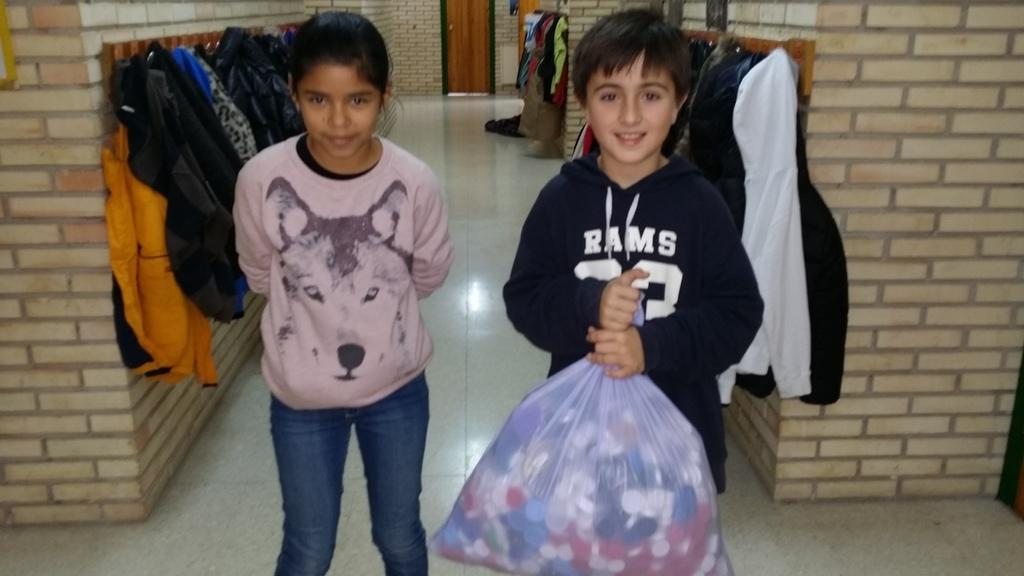How many people are in the image? There are two people in the image, a girl and a boy. What is the boy holding in the image? The boy is holding a cover. What can be seen in the background of the image? In the background, dresses are hanged on a hanger. How many books are stacked on the unit in the image? There is no unit or books present in the image. 